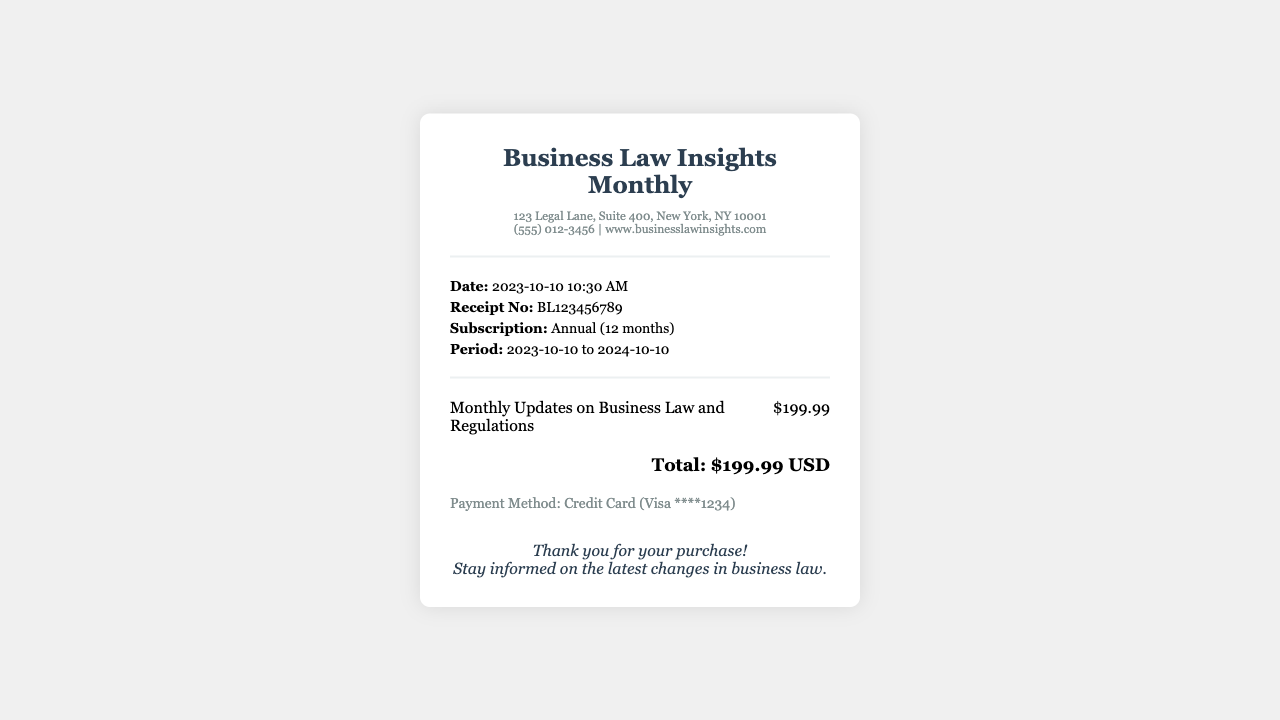What is the subscription period? The subscription period is indicated in the document as starting from October 10, 2023, to October 10, 2024.
Answer: 2023-10-10 to 2024-10-10 What is the receipt number? The receipt number is displayed prominently in the transaction info section.
Answer: BL123456789 What is the total amount paid? The total amount is the sum displayed at the bottom of the receipt for the subscription service.
Answer: $199.99 USD Who is the merchant? The document lists the merchant's name clearly at the top along with the address.
Answer: Business Law Insights Monthly What payment method was used? The payment method is specified in the payment info section of the receipt.
Answer: Credit Card (Visa ****1234) How many months does the subscription cover? The subscription is noted as an annual subscription, covering 12 months.
Answer: 12 months What service is being subscribed to? The document directly states what type of updates are included in the subscription service.
Answer: Monthly Updates on Business Law and Regulations What is the date of the transaction? The date of the transaction is found in the transaction info section, reflecting when the receipt was issued.
Answer: 2023-10-10 10:30 AM 